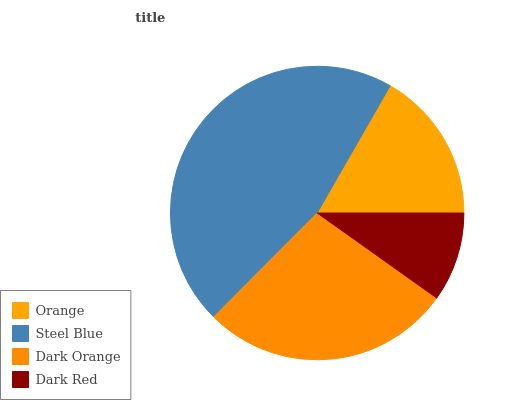Is Dark Red the minimum?
Answer yes or no. Yes. Is Steel Blue the maximum?
Answer yes or no. Yes. Is Dark Orange the minimum?
Answer yes or no. No. Is Dark Orange the maximum?
Answer yes or no. No. Is Steel Blue greater than Dark Orange?
Answer yes or no. Yes. Is Dark Orange less than Steel Blue?
Answer yes or no. Yes. Is Dark Orange greater than Steel Blue?
Answer yes or no. No. Is Steel Blue less than Dark Orange?
Answer yes or no. No. Is Dark Orange the high median?
Answer yes or no. Yes. Is Orange the low median?
Answer yes or no. Yes. Is Steel Blue the high median?
Answer yes or no. No. Is Steel Blue the low median?
Answer yes or no. No. 